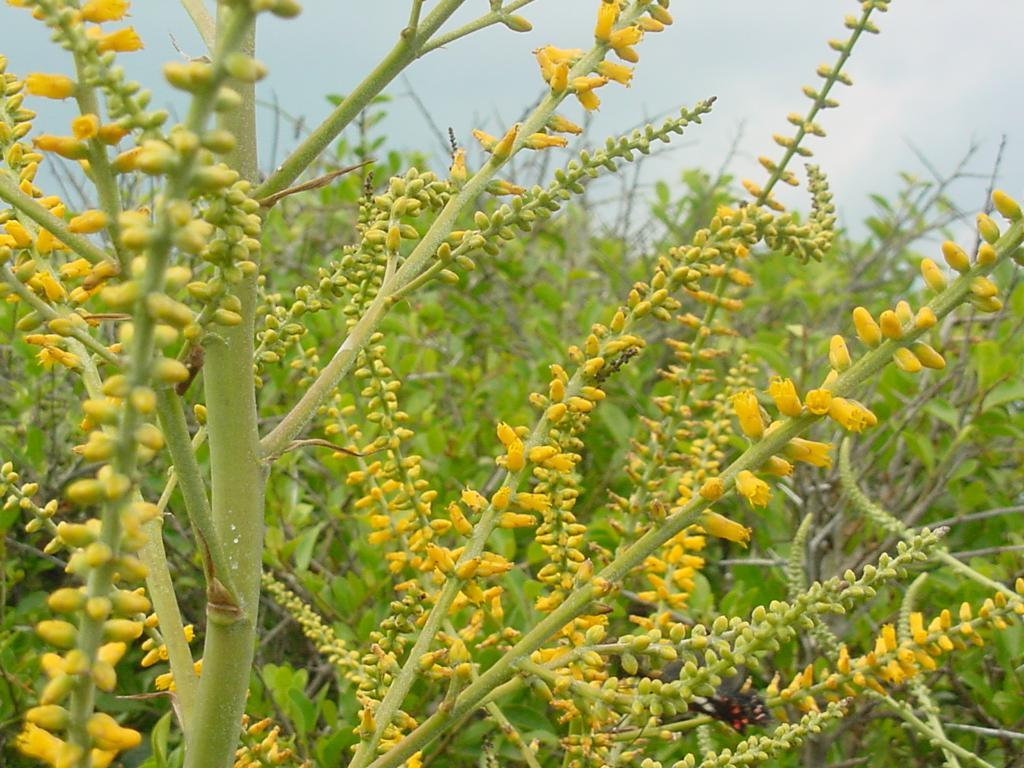What type of living organisms can be seen in the image? Plants and flowers are visible in the image. What color are the plants in the image? The plants are green in color. What color are the flowers in the image? The flowers are yellow in color. What can be seen in the background of the image? The sky is visible in the background of the image. How does the image convey a sense of disgust? The image does not convey a sense of disgust; it features plants and flowers with no indication of any negative emotions or feelings. 